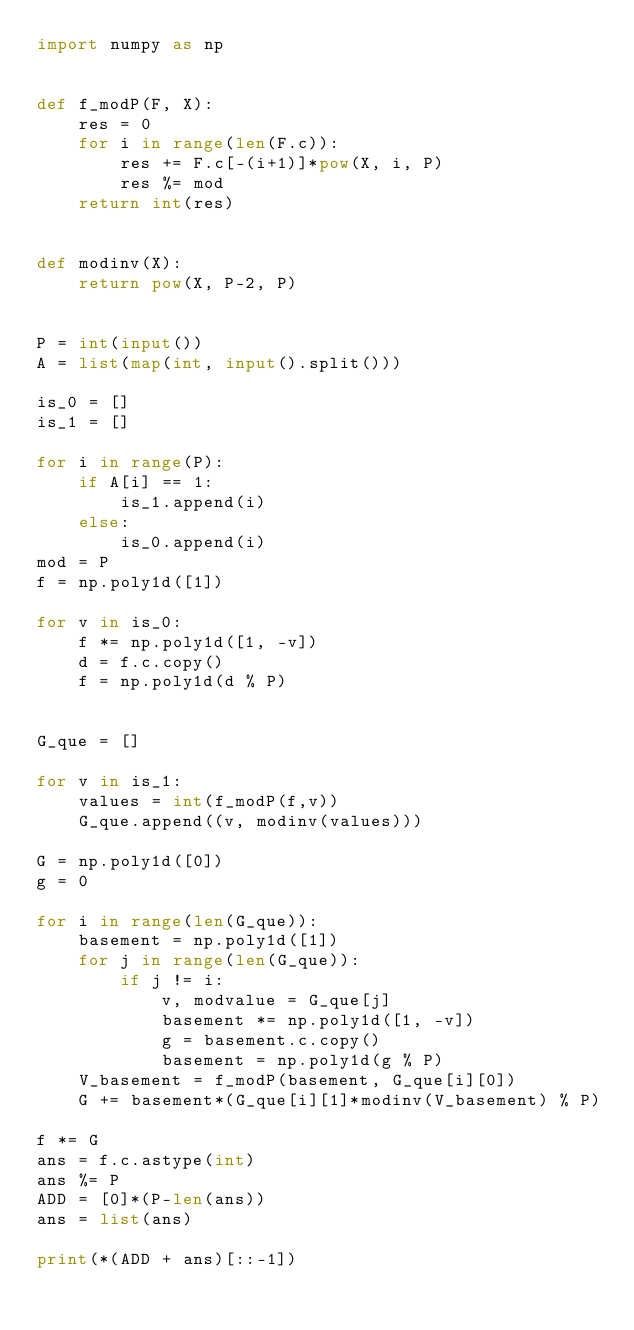Convert code to text. <code><loc_0><loc_0><loc_500><loc_500><_Python_>import numpy as np


def f_modP(F, X):
    res = 0
    for i in range(len(F.c)):
        res += F.c[-(i+1)]*pow(X, i, P)
        res %= mod
    return int(res)


def modinv(X):
    return pow(X, P-2, P)


P = int(input())
A = list(map(int, input().split()))

is_0 = []
is_1 = []

for i in range(P):
    if A[i] == 1:
        is_1.append(i)
    else:
        is_0.append(i)
mod = P
f = np.poly1d([1])

for v in is_0:
    f *= np.poly1d([1, -v])
    d = f.c.copy()
    f = np.poly1d(d % P)


G_que = []

for v in is_1:
    values = int(f_modP(f,v))
    G_que.append((v, modinv(values)))

G = np.poly1d([0])
g = 0

for i in range(len(G_que)):
    basement = np.poly1d([1])
    for j in range(len(G_que)):
        if j != i:
            v, modvalue = G_que[j]
            basement *= np.poly1d([1, -v])
            g = basement.c.copy()
            basement = np.poly1d(g % P)
    V_basement = f_modP(basement, G_que[i][0])
    G += basement*(G_que[i][1]*modinv(V_basement) % P)

f *= G
ans = f.c.astype(int)
ans %= P
ADD = [0]*(P-len(ans))
ans = list(ans)

print(*(ADD + ans)[::-1])
</code> 